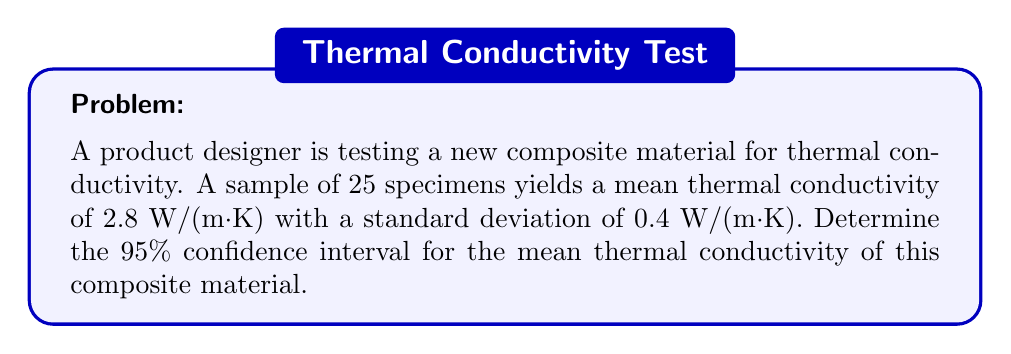Can you solve this math problem? To determine the confidence interval, we'll follow these steps:

1. Identify the known values:
   - Sample size: $n = 25$
   - Sample mean: $\bar{x} = 2.8$ W/(m·K)
   - Sample standard deviation: $s = 0.4$ W/(m·K)
   - Confidence level: 95% (α = 0.05)

2. Find the critical value ($t$-value) for a 95% confidence interval:
   - Degrees of freedom: $df = n - 1 = 24$
   - Using a t-distribution table or calculator, find $t_{0.025, 24} = 2.064$

3. Calculate the margin of error:
   $E = t_{\frac{\alpha}{2}, n-1} \cdot \frac{s}{\sqrt{n}}$
   $E = 2.064 \cdot \frac{0.4}{\sqrt{25}} = 0.165$ W/(m·K)

4. Construct the confidence interval:
   $CI = \bar{x} \pm E$
   $CI = 2.8 \pm 0.165$ W/(m·K)

5. Express the final interval:
   $(2.8 - 0.165, 2.8 + 0.165)$ = $(2.635, 2.965)$ W/(m·K)

Therefore, we can be 95% confident that the true mean thermal conductivity of the composite material lies between 2.635 W/(m·K) and 2.965 W/(m·K).
Answer: (2.635, 2.965) W/(m·K) 